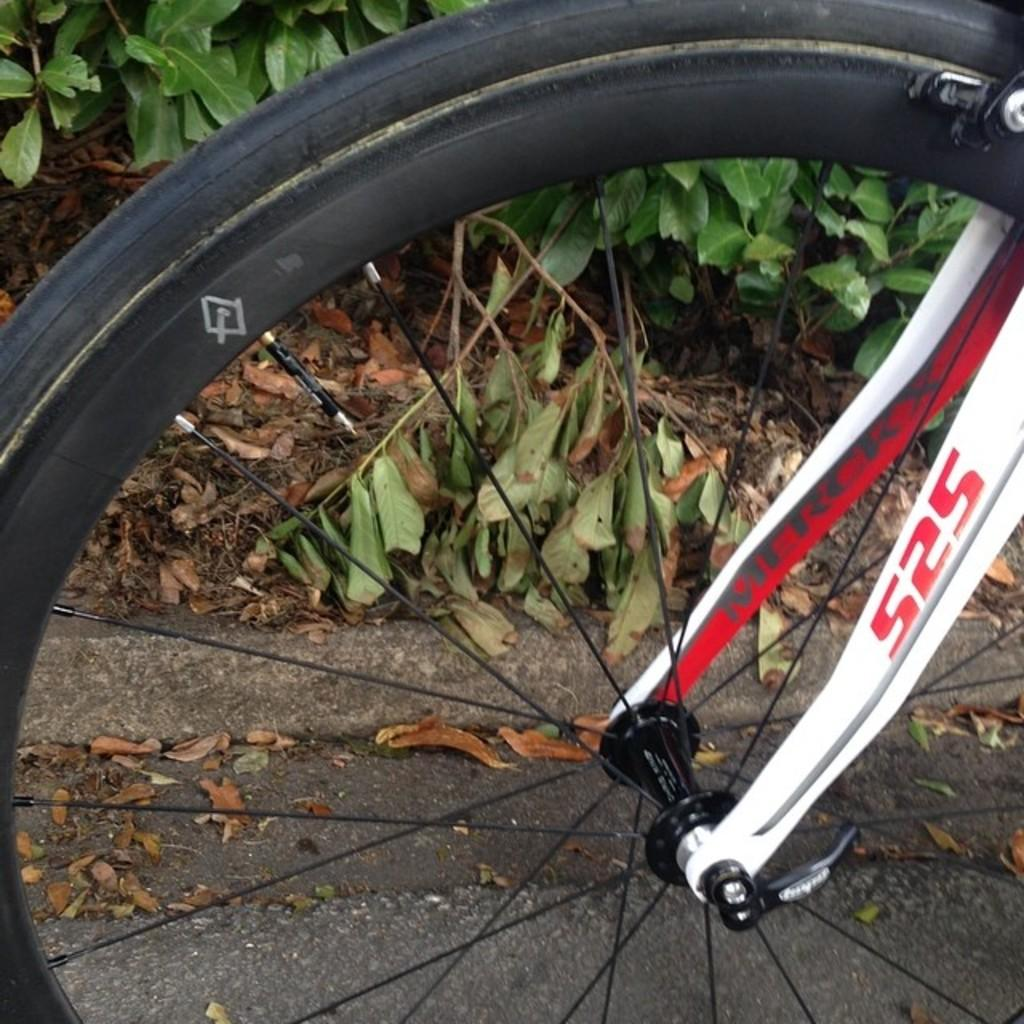What is the main object in the picture? There is a wheel in the picture. Is the wheel connected to anything? Yes, the wheel is attached to something. What can be seen on the ground in the picture? There are dry leaves on the floor. What is visible in the background of the picture? There are plants in the background of the picture. How does the tent fit into the picture? There is no tent present in the image. What impulse led to the creation of the afterthought in the picture? There is no afterthought or impulse mentioned in the image. 